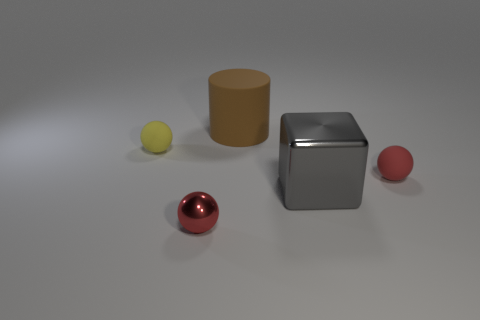What color is the tiny sphere that is both on the left side of the metal block and in front of the yellow rubber object?
Give a very brief answer. Red. What number of tiny rubber things have the same color as the metal ball?
Give a very brief answer. 1. What number of balls are metallic objects or small rubber things?
Keep it short and to the point. 3. What color is the cube that is the same size as the brown object?
Ensure brevity in your answer.  Gray. There is a tiny matte sphere that is to the right of the rubber object that is behind the yellow thing; are there any brown objects that are on the right side of it?
Your answer should be compact. No. What size is the metallic ball?
Provide a succinct answer. Small. What number of things are big green rubber cylinders or red objects?
Provide a succinct answer. 2. There is another big thing that is made of the same material as the yellow object; what is its color?
Your response must be concise. Brown. Does the small red object to the left of the red matte thing have the same shape as the red matte thing?
Give a very brief answer. Yes. What number of objects are either objects behind the yellow thing or rubber objects in front of the brown cylinder?
Provide a short and direct response. 3. 